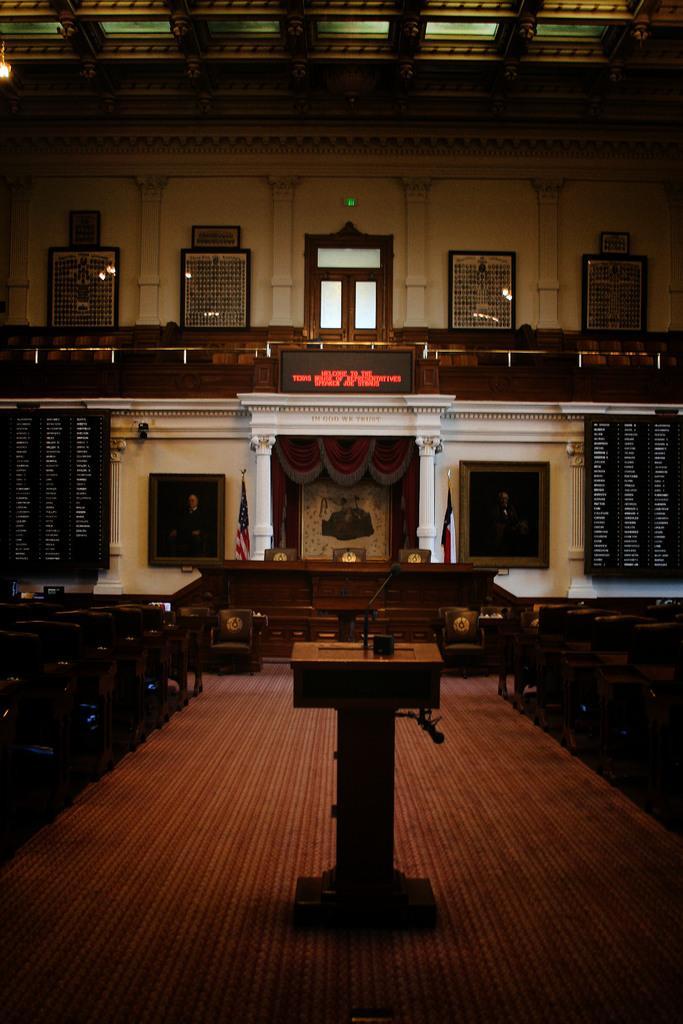Could you give a brief overview of what you see in this image? In this image in the center there is a podium and on the podium there is a mic. On the left side there are empty benches and in the background there are flags, there are boards with some text written on it and there are frames on the wall and on the right side there empty benches. 